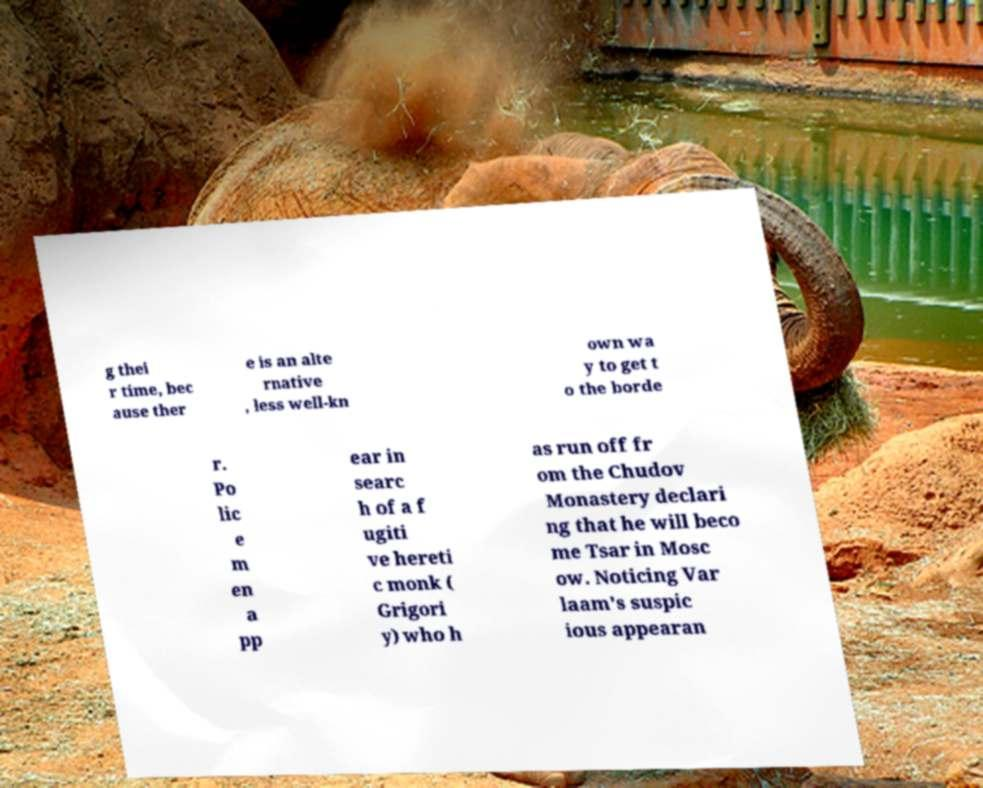Can you accurately transcribe the text from the provided image for me? g thei r time, bec ause ther e is an alte rnative , less well-kn own wa y to get t o the borde r. Po lic e m en a pp ear in searc h of a f ugiti ve hereti c monk ( Grigori y) who h as run off fr om the Chudov Monastery declari ng that he will beco me Tsar in Mosc ow. Noticing Var laam's suspic ious appearan 